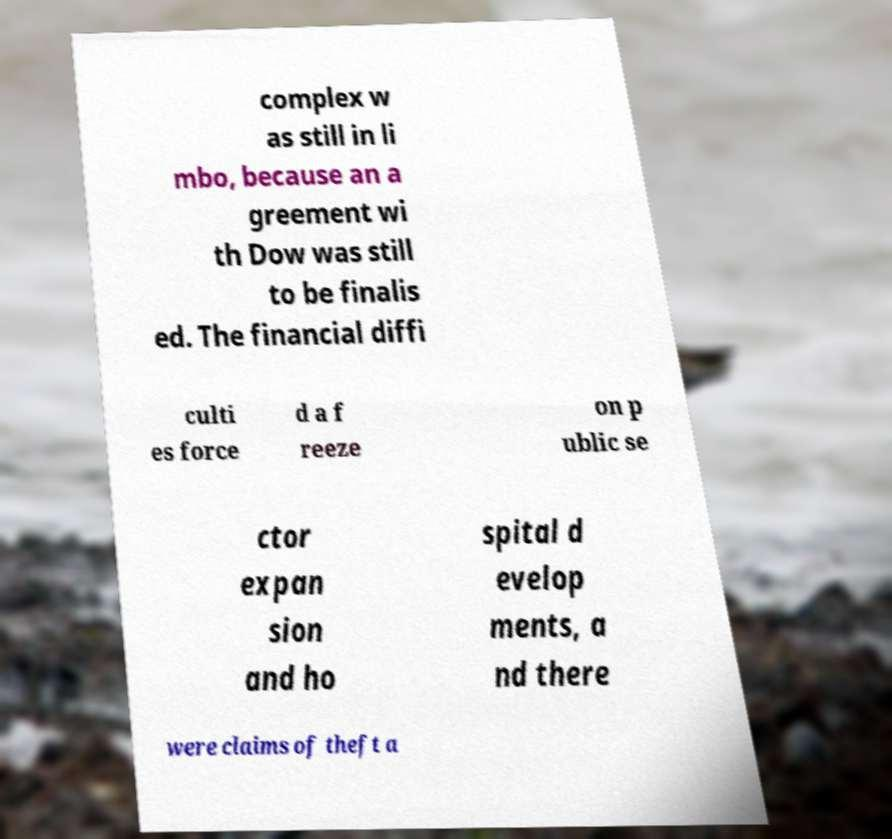Please read and relay the text visible in this image. What does it say? complex w as still in li mbo, because an a greement wi th Dow was still to be finalis ed. The financial diffi culti es force d a f reeze on p ublic se ctor expan sion and ho spital d evelop ments, a nd there were claims of theft a 